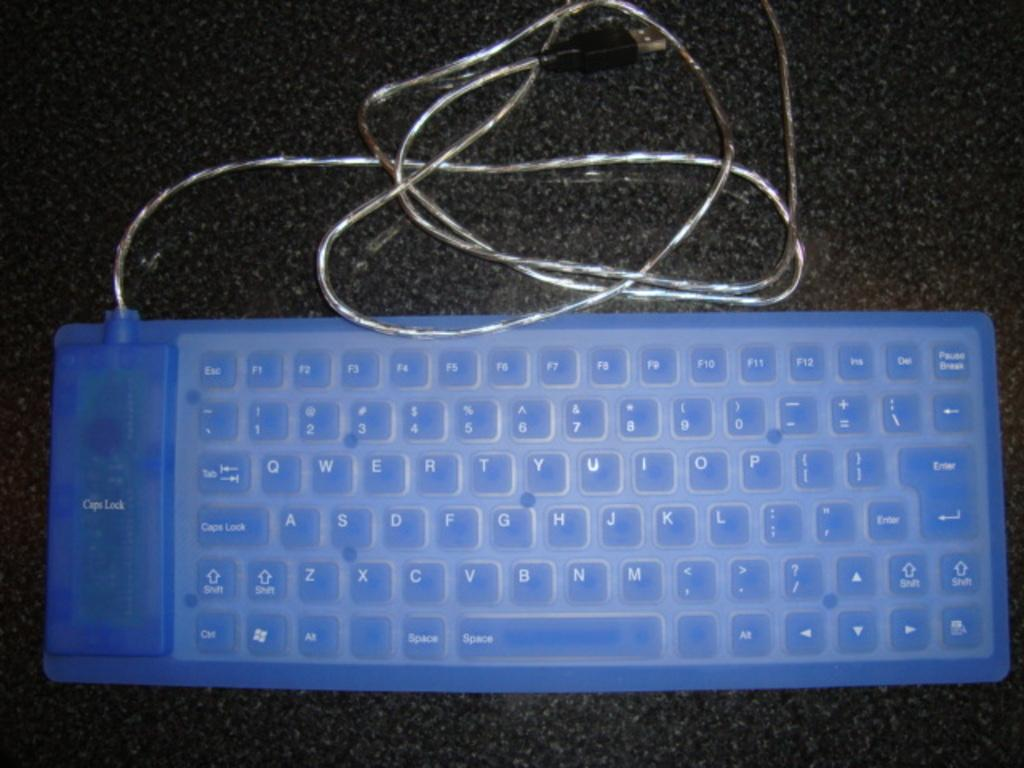Provide a one-sentence caption for the provided image. A blue plastic keyboard shows the words Caps Lock in two different places. 